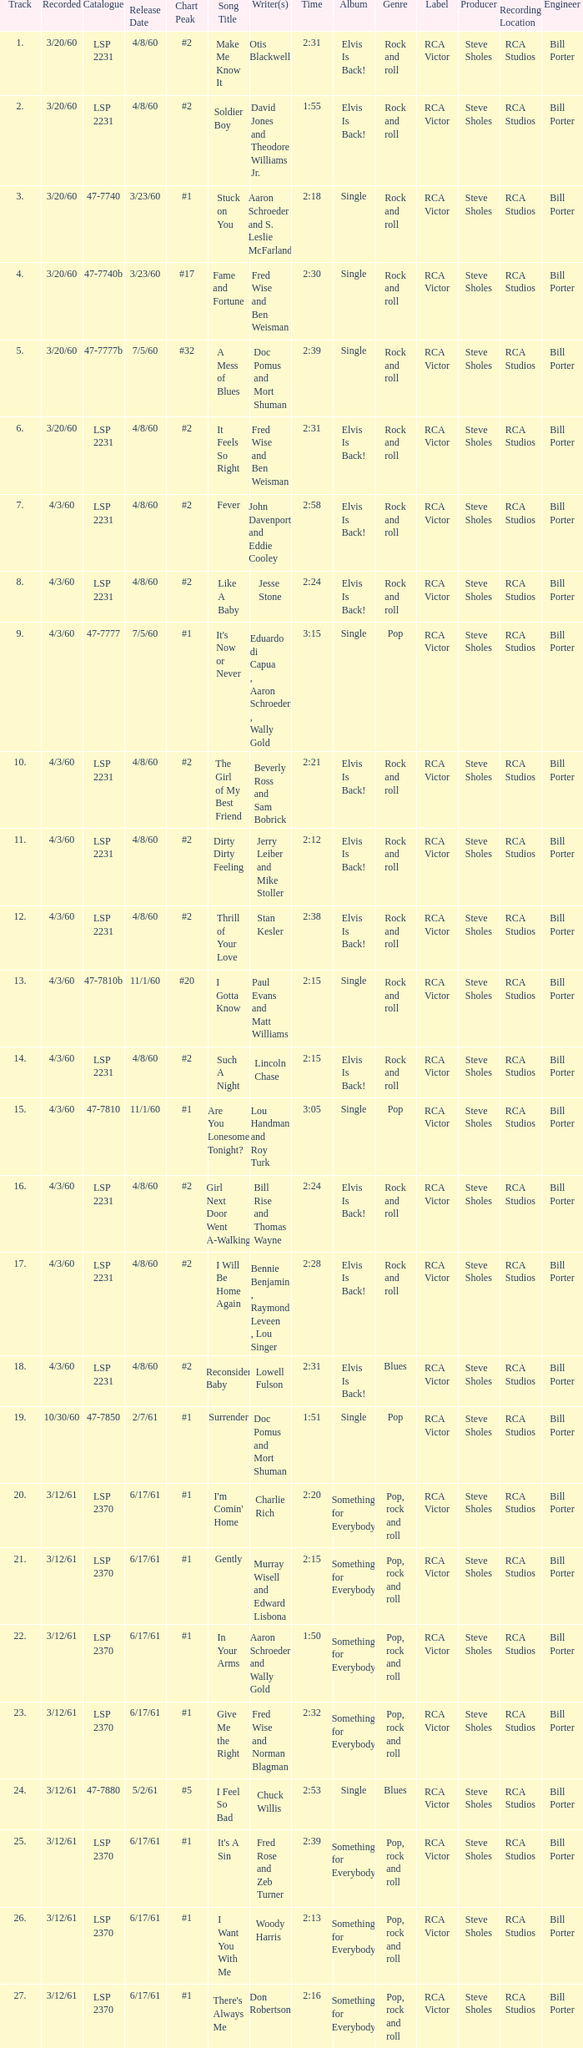What catalogue is the song It's Now or Never? 47-7777. 